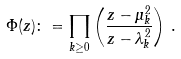<formula> <loc_0><loc_0><loc_500><loc_500>\Phi ( z ) \colon = \prod _ { k \geq 0 } \left ( \frac { z - \mu _ { k } ^ { 2 } } { z - \lambda _ { k } ^ { 2 } } \right ) \, .</formula> 